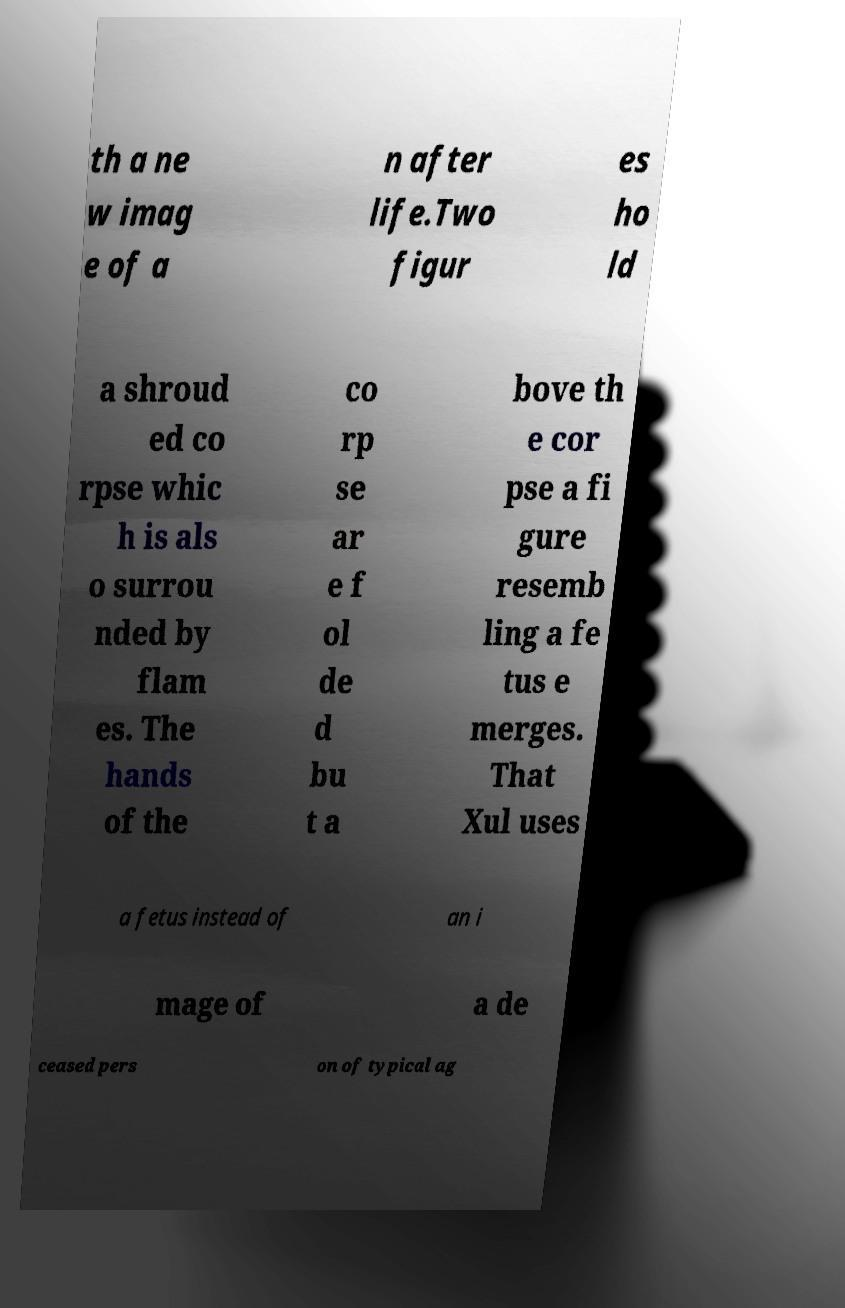For documentation purposes, I need the text within this image transcribed. Could you provide that? th a ne w imag e of a n after life.Two figur es ho ld a shroud ed co rpse whic h is als o surrou nded by flam es. The hands of the co rp se ar e f ol de d bu t a bove th e cor pse a fi gure resemb ling a fe tus e merges. That Xul uses a fetus instead of an i mage of a de ceased pers on of typical ag 